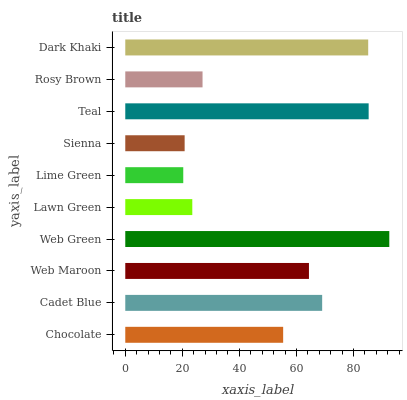Is Lime Green the minimum?
Answer yes or no. Yes. Is Web Green the maximum?
Answer yes or no. Yes. Is Cadet Blue the minimum?
Answer yes or no. No. Is Cadet Blue the maximum?
Answer yes or no. No. Is Cadet Blue greater than Chocolate?
Answer yes or no. Yes. Is Chocolate less than Cadet Blue?
Answer yes or no. Yes. Is Chocolate greater than Cadet Blue?
Answer yes or no. No. Is Cadet Blue less than Chocolate?
Answer yes or no. No. Is Web Maroon the high median?
Answer yes or no. Yes. Is Chocolate the low median?
Answer yes or no. Yes. Is Chocolate the high median?
Answer yes or no. No. Is Web Maroon the low median?
Answer yes or no. No. 